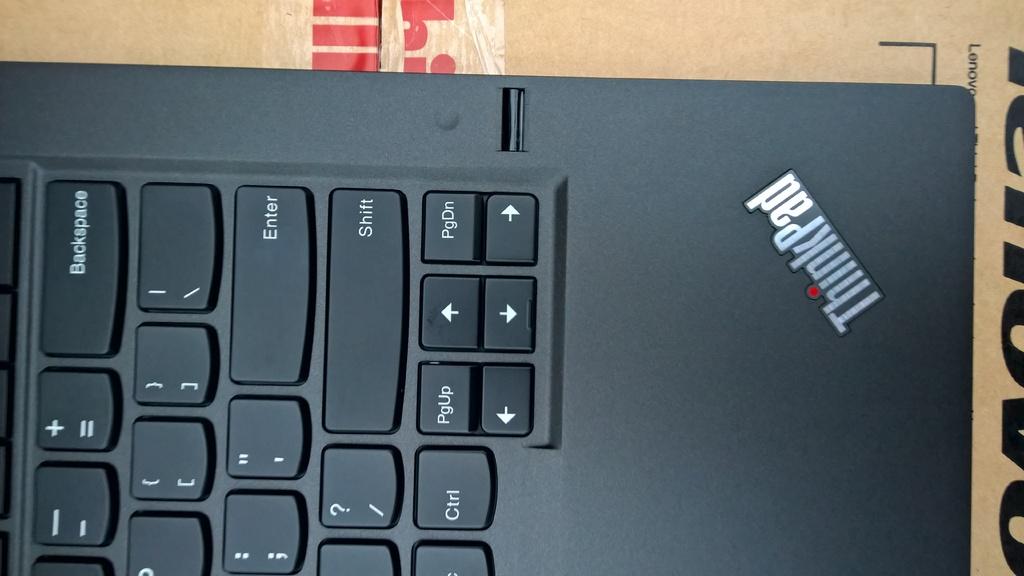What type of laptop is this?
Keep it short and to the point. Thinkpad. What is the top button on the top right of the keyboard?
Provide a succinct answer. Backspace. 